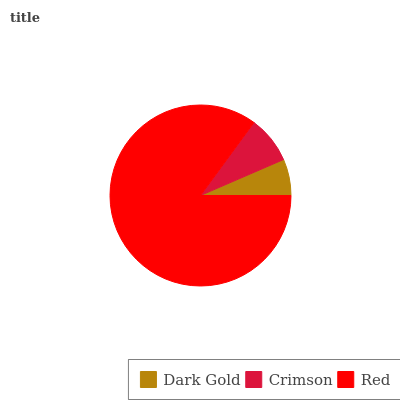Is Dark Gold the minimum?
Answer yes or no. Yes. Is Red the maximum?
Answer yes or no. Yes. Is Crimson the minimum?
Answer yes or no. No. Is Crimson the maximum?
Answer yes or no. No. Is Crimson greater than Dark Gold?
Answer yes or no. Yes. Is Dark Gold less than Crimson?
Answer yes or no. Yes. Is Dark Gold greater than Crimson?
Answer yes or no. No. Is Crimson less than Dark Gold?
Answer yes or no. No. Is Crimson the high median?
Answer yes or no. Yes. Is Crimson the low median?
Answer yes or no. Yes. Is Red the high median?
Answer yes or no. No. Is Red the low median?
Answer yes or no. No. 